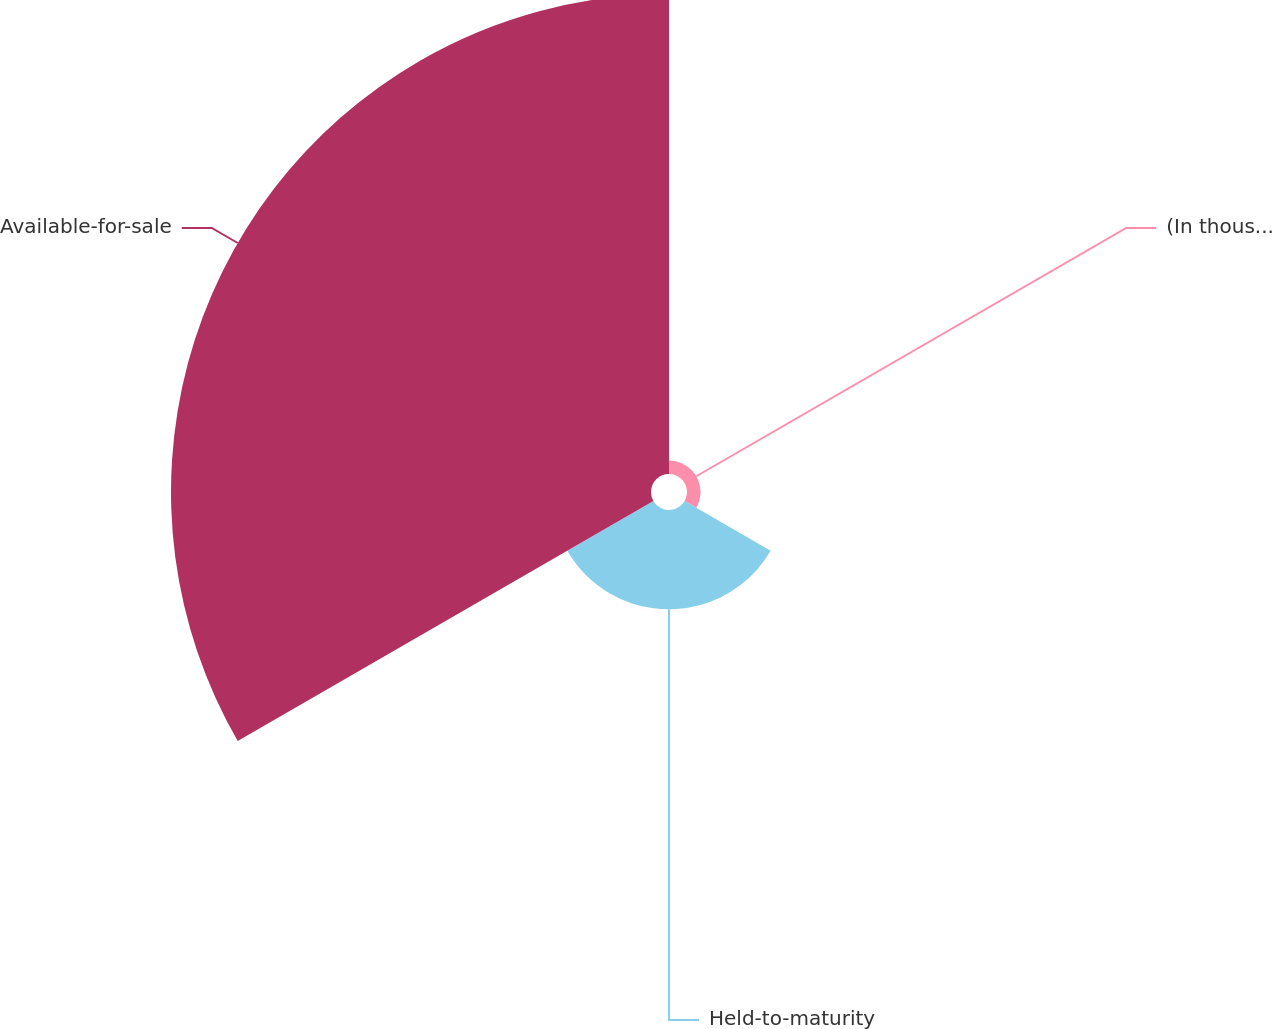Convert chart to OTSL. <chart><loc_0><loc_0><loc_500><loc_500><pie_chart><fcel>(In thousands)<fcel>Held-to-maturity<fcel>Available-for-sale<nl><fcel>2.28%<fcel>16.76%<fcel>80.96%<nl></chart> 